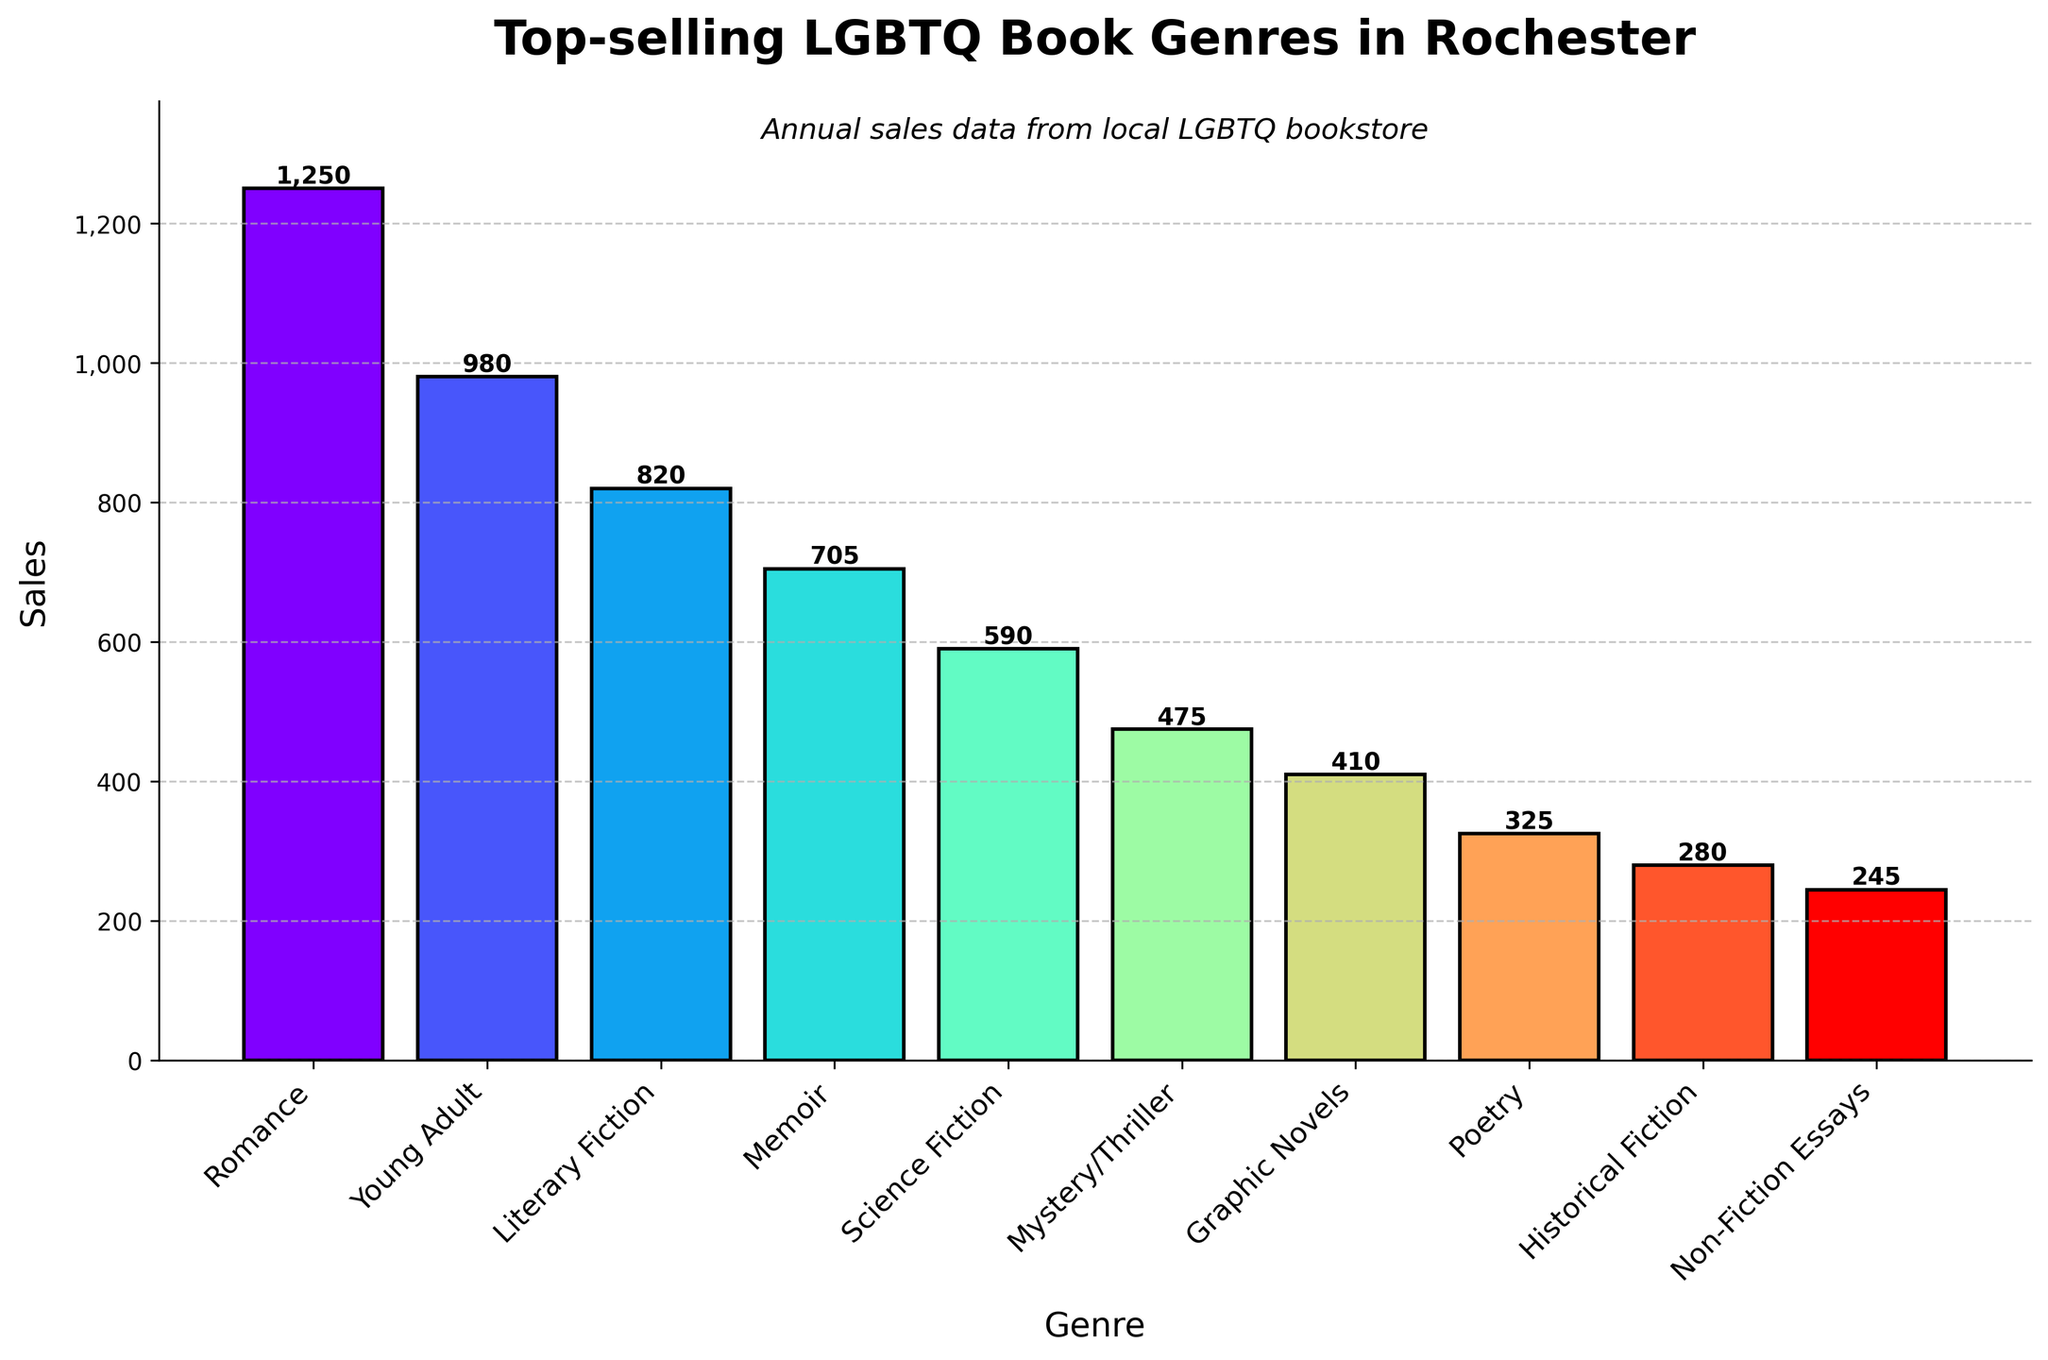What genre has the highest sales? Look at the bar chart and find the bar with the greatest height; according to the chart, the "Romance" genre has the tallest bar. Thus, "Romance" has the highest sales.
Answer: Romance How do the sales of "Young Adult" genre compare with "Science Fiction"? Compare the heights of the bars for "Young Adult" and "Science Fiction" genres. The "Young Adult" genre has sales of 980, while the "Science Fiction" genre has sales of 590. 980 is greater than 590, so "Young Adult" has higher sales.
Answer: Young Adult What is the difference in sales between the highest and lowest selling genres? Identify the highest sale (Romance with 1250) and the lowest sale (Non-Fiction Essays with 245) from the bars. Calculate the difference: 1250 - 245 = 1005.
Answer: 1005 Which genre has the third highest sales? Rank the genres based on the height of their bars. The third highest bar represents the "Literary Fiction" genre with sales of 820.
Answer: Literary Fiction What are the total sales for "Historical Fiction" and "Poetry" genres combined? Find the bars for "Historical Fiction" and "Poetry". "Historical Fiction" has sales of 280, and "Poetry" has sales of 325. Add them together: 280 + 325 = 605.
Answer: 605 What is the average sales figure for the top three genres? Identify the top three genres: "Romance" (1250), "Young Adult" (980), and "Literary Fiction" (820). Calculate the average: (1250 + 980 + 820) / 3 = 1016.67.
Answer: 1016.67 How many genres have sales greater than 500? Count the number of bars that have heights greater than the 500 mark. There are five genres ("Romance," "Young Adult," "Literary Fiction," "Memoir," and "Science Fiction") with sales greater than 500.
Answer: 5 What percentage of the total sales does the "Memoir" genre represent? Calculate the total sales by summing all the genres' sales (1250 + 980 + 820 + 705 + 590 + 475 + 410 + 325 + 280 + 245 = 6080). Then, find the percentage: (705 / 6080) * 100 ≈ 11.59%.
Answer: 11.59% Which genre is represented by the lightest color in the bar chart? Observe the color gradients in the bars; the lightest color represents the bar for the "Non-Fiction Essays" genre.
Answer: Non-Fiction Essays Is the sum of sales for the "Poetry" and "Science Fiction" genres greater than the sales of the "Memoir" genre? Add the sales of "Poetry" (325) and "Science Fiction" (590) to get 325 + 590 = 915. Compare this sum to the sales of "Memoir" (705). Since 915 is greater than 705, yes, it is greater.
Answer: Yes 